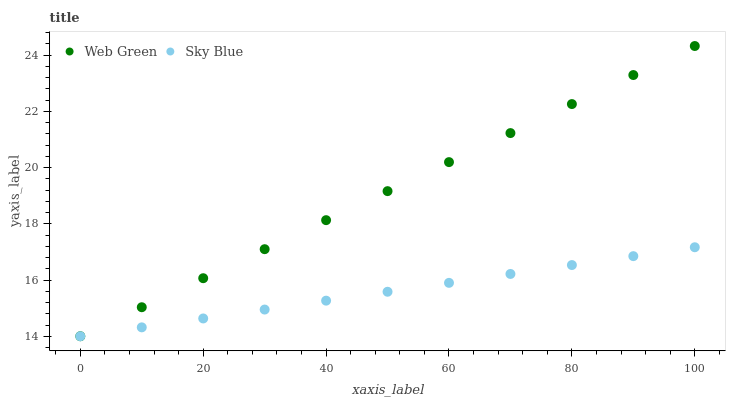Does Sky Blue have the minimum area under the curve?
Answer yes or no. Yes. Does Web Green have the maximum area under the curve?
Answer yes or no. Yes. Does Web Green have the minimum area under the curve?
Answer yes or no. No. Is Sky Blue the smoothest?
Answer yes or no. Yes. Is Web Green the roughest?
Answer yes or no. Yes. Is Web Green the smoothest?
Answer yes or no. No. Does Sky Blue have the lowest value?
Answer yes or no. Yes. Does Web Green have the highest value?
Answer yes or no. Yes. Does Sky Blue intersect Web Green?
Answer yes or no. Yes. Is Sky Blue less than Web Green?
Answer yes or no. No. Is Sky Blue greater than Web Green?
Answer yes or no. No. 